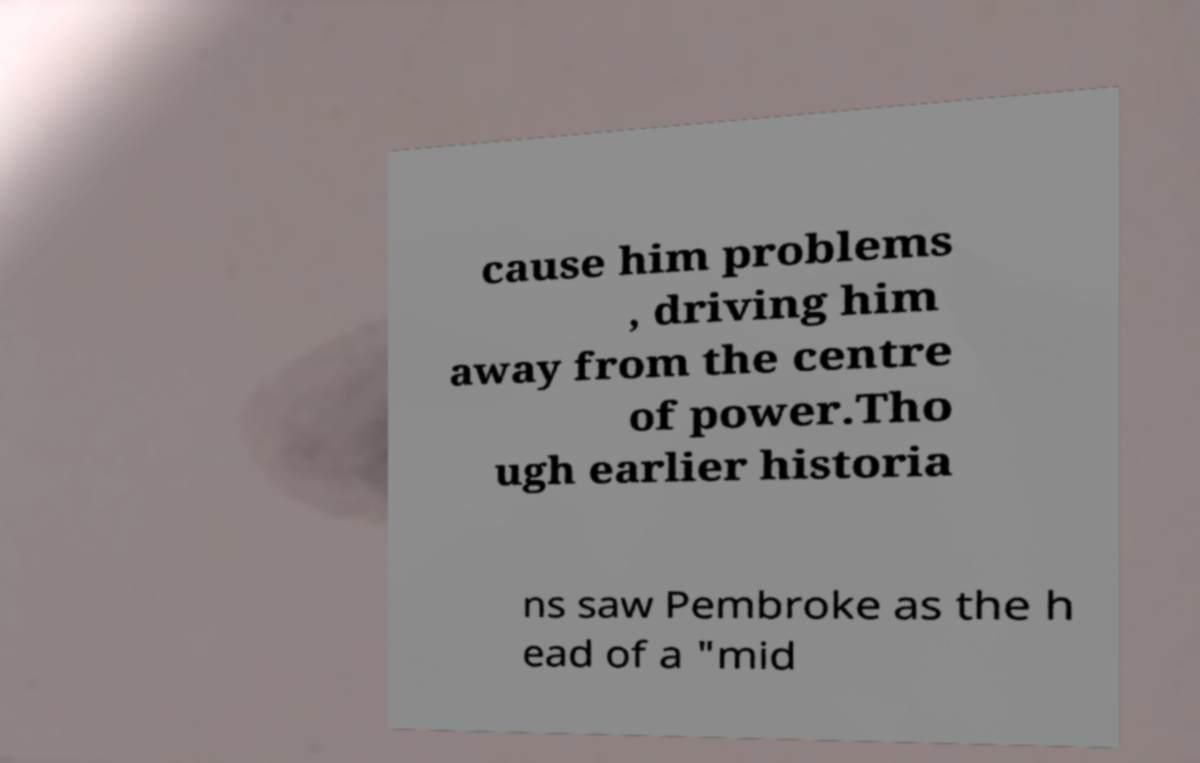For documentation purposes, I need the text within this image transcribed. Could you provide that? cause him problems , driving him away from the centre of power.Tho ugh earlier historia ns saw Pembroke as the h ead of a "mid 